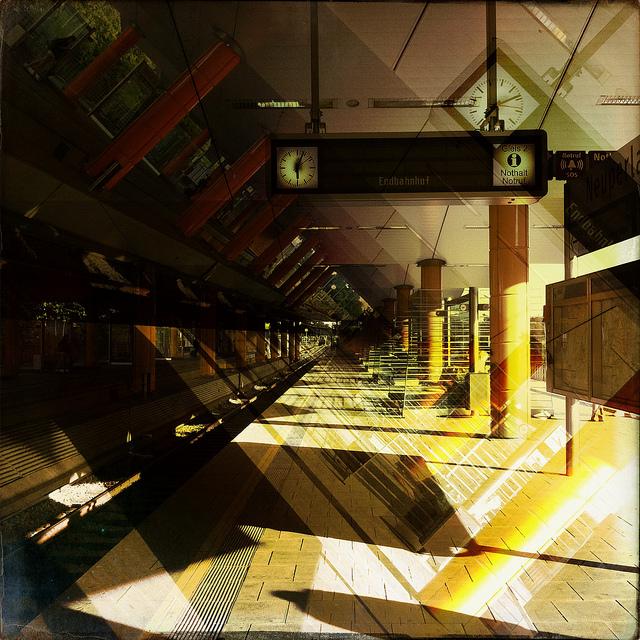Are both clocks real?
Answer briefly. No. Was this picture taken indoors?
Be succinct. Yes. What is hanging from the ceiling?
Be succinct. Clock. What is this building used for?
Quick response, please. Trains. Are there any windows in the picture?
Concise answer only. No. 